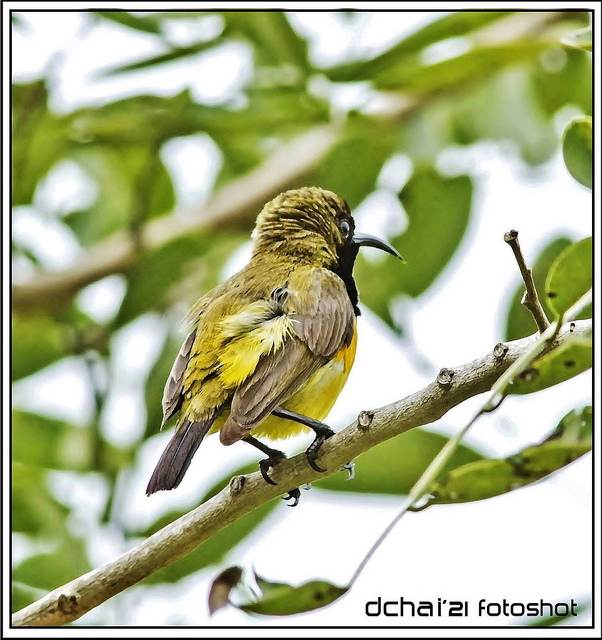Identify the text displayed in this image. fotoshot dchai'2I 